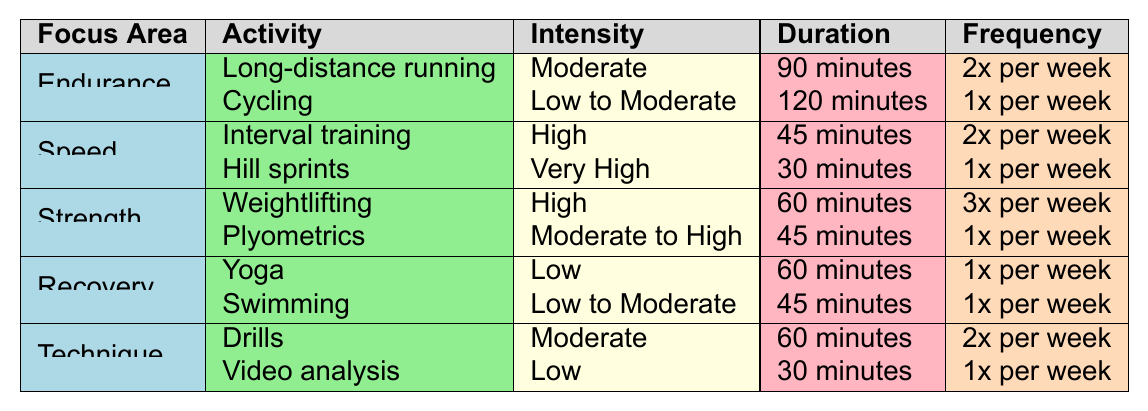What is the frequency of long-distance running sessions in Benjamin's training program? The training program indicates that long-distance running is performed 2 times per week.
Answer: 2x per week Which focus area has the highest intensity activity listed? The Speed focus area contains the activity "Hill sprints" with an intensity categorized as "Very High."
Answer: Speed How many different types of sessions are included under the Strength focus area? There are two sessions listed under Strength: Weightlifting and Plyometrics.
Answer: 2 What is the total weekly duration of the Endurance training sessions? The total duration is calculated as follows: (90 minutes x 2 sessions) + (120 minutes x 1 session) = 180 + 120 = 300 minutes.
Answer: 300 minutes Are there any recovery activities with a "Low" intensity level? Yes, Yoga has a "Low" intensity level listed under the Recovery focus area.
Answer: Yes Which focus area has the most sessions per week? The Strength focus area has 3 sessions of Weightlifting per week, more than any other focus area.
Answer: Strength What is the average duration of sessions in the Technique focus area? The average is calculated as follows: (60 minutes + 30 minutes) / 2 = 45 minutes.
Answer: 45 minutes Is cycling performed more frequently than swimming in the training program? Cycling is scheduled 1 time per week, while swimming is also scheduled for 1 time per week, making their frequencies equal.
Answer: No What is the combined duration of the Speed focus area activities? The total duration for Speed activities is (45 minutes x 2 sessions) + (30 minutes x 1 session) = 90 + 30 = 120 minutes.
Answer: 120 minutes Which activity within the Recovery focus area has a longer duration? Swimming has a duration of 45 minutes, while Yoga has a duration of 60 minutes, so Yoga is the longer activity.
Answer: Yoga 